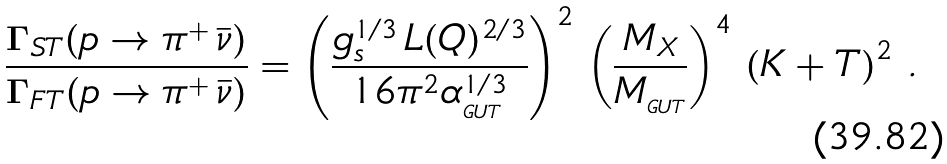Convert formula to latex. <formula><loc_0><loc_0><loc_500><loc_500>\frac { \Gamma _ { S T } ( p \rightarrow \pi ^ { + } \, \bar { \nu } ) } { \Gamma _ { F T } ( p \rightarrow \pi ^ { + } \, \bar { \nu } ) } = \left ( \frac { g ^ { 1 / 3 } _ { s } \, L ( Q ) ^ { 2 / 3 } } { 1 6 \pi ^ { 2 } \alpha ^ { 1 / 3 } _ { _ { G U T } } } \right ) ^ { 2 } \, \left ( \frac { M _ { X } } { M _ { _ { G U T } } } \right ) ^ { 4 } \, \left ( K + T \right ) ^ { 2 } \, .</formula> 